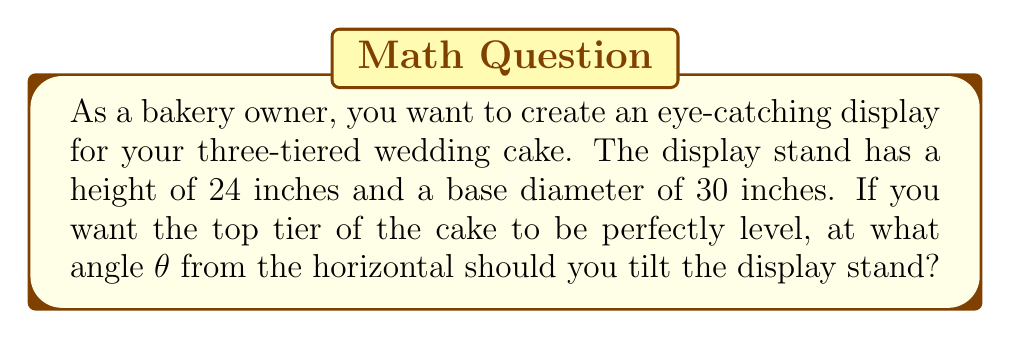Help me with this question. Let's approach this step-by-step:

1) We can visualize this as a right triangle, where:
   - The height of the stand is the opposite side
   - Half of the base diameter is the adjacent side
   - The angle we're looking for is the angle between the base and the hypotenuse

2) We know:
   - Opposite (height) = 24 inches
   - Adjacent (half of base diameter) = 30/2 = 15 inches

3) To find the angle, we can use the tangent function:

   $$\tan(\theta) = \frac{\text{opposite}}{\text{adjacent}}$$

4) Substituting our values:

   $$\tan(\theta) = \frac{24}{15}$$

5) To solve for θ, we need to use the inverse tangent (arctan or tan^(-1)):

   $$\theta = \tan^{-1}(\frac{24}{15})$$

6) Using a calculator or computer:

   $$\theta \approx 57.99^\circ$$

7) Rounding to the nearest degree:

   $$\theta \approx 58^\circ$$

This means the display stand should be tilted at approximately 58° from the horizontal to ensure the top tier of the cake is level.

[asy]
import geometry;

size(200);

pair A = (0,0);
pair B = (15,0);
pair C = (0,24);

draw(A--B--C--A);

label("24\"", C--A, W);
label("15\"", A--B, S);
label("θ", A, NE);

draw(rightanglemark(B,A,C,8));
[/asy]
Answer: $58^\circ$ 